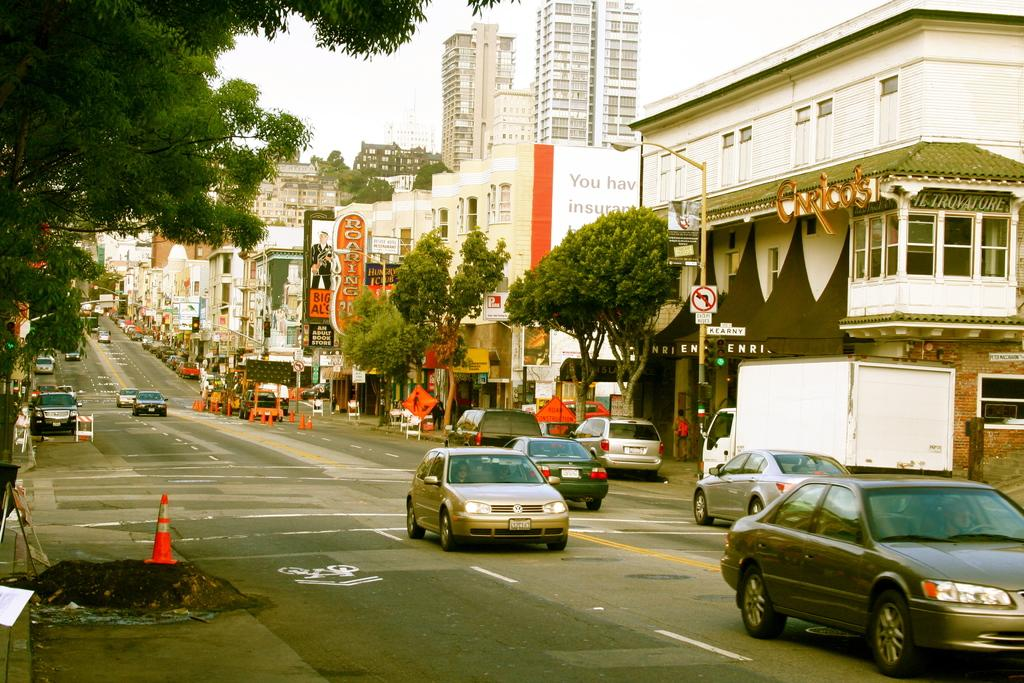What type of vehicles can be seen on the road in the image? There are cars on the road in the image. What objects are present to guide or control traffic in the image? Traffic cones are present in the image. What architectural features can be seen on the buildings in the image? There are buildings with windows in the image. What type of vegetation is visible in the image? Trees are visible in the image. What is visible in the background of the image? The sky is visible in the background of the image. What type of waste is being collected by the tax collector in the image? There is no waste or tax collector present in the image. What is the ground made of in the image? The ground is not mentioned in the provided facts, so it cannot be determined from the image. 